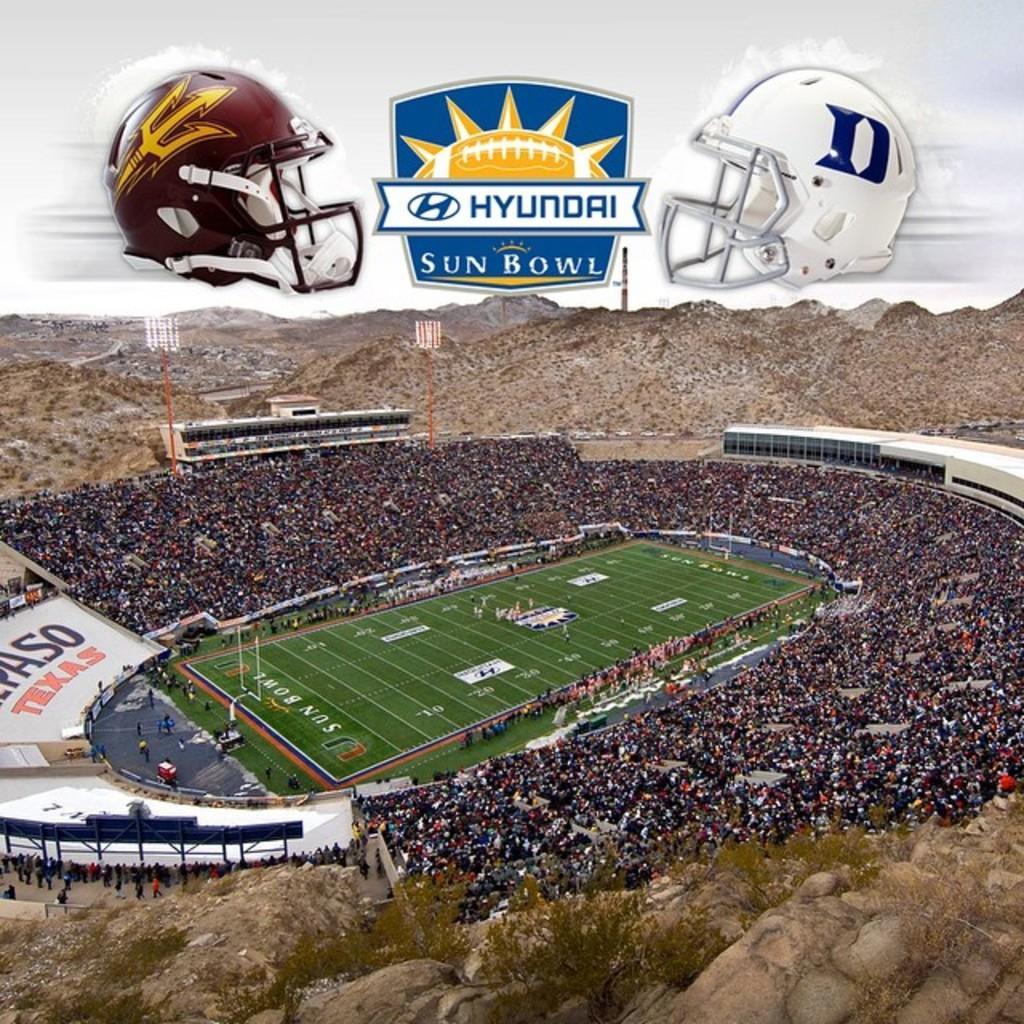Can you describe this image briefly? In the picture we can see a Ariel view of the stadium with a playground and around it we can see audience and in the background we can see some hills. 